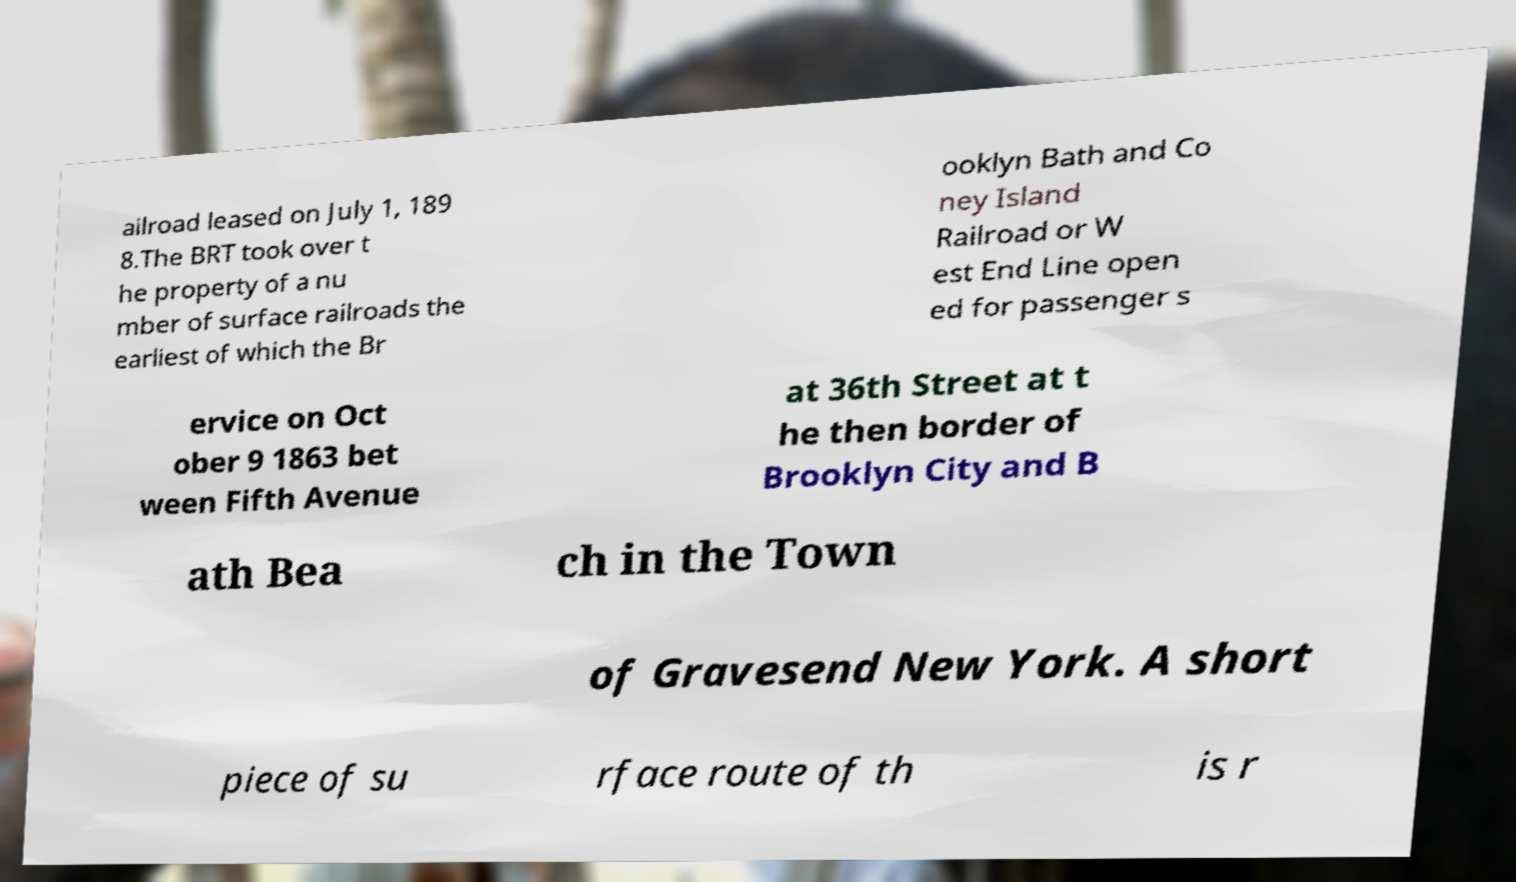I need the written content from this picture converted into text. Can you do that? ailroad leased on July 1, 189 8.The BRT took over t he property of a nu mber of surface railroads the earliest of which the Br ooklyn Bath and Co ney Island Railroad or W est End Line open ed for passenger s ervice on Oct ober 9 1863 bet ween Fifth Avenue at 36th Street at t he then border of Brooklyn City and B ath Bea ch in the Town of Gravesend New York. A short piece of su rface route of th is r 